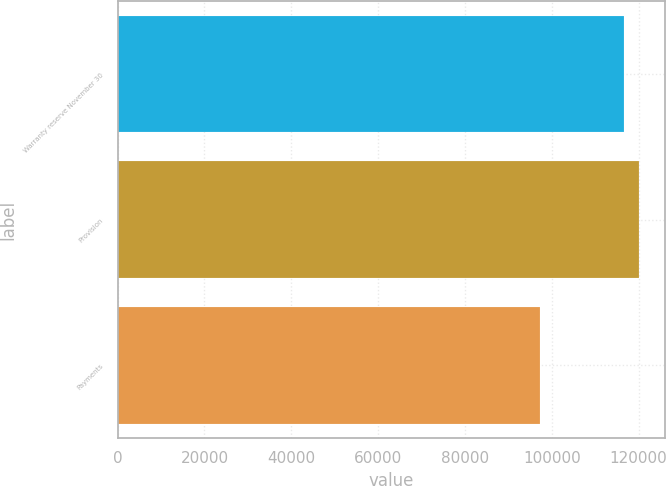Convert chart to OTSL. <chart><loc_0><loc_0><loc_500><loc_500><bar_chart><fcel>Warranty reserve November 30<fcel>Provision<fcel>Payments<nl><fcel>116571<fcel>120167<fcel>97202<nl></chart> 